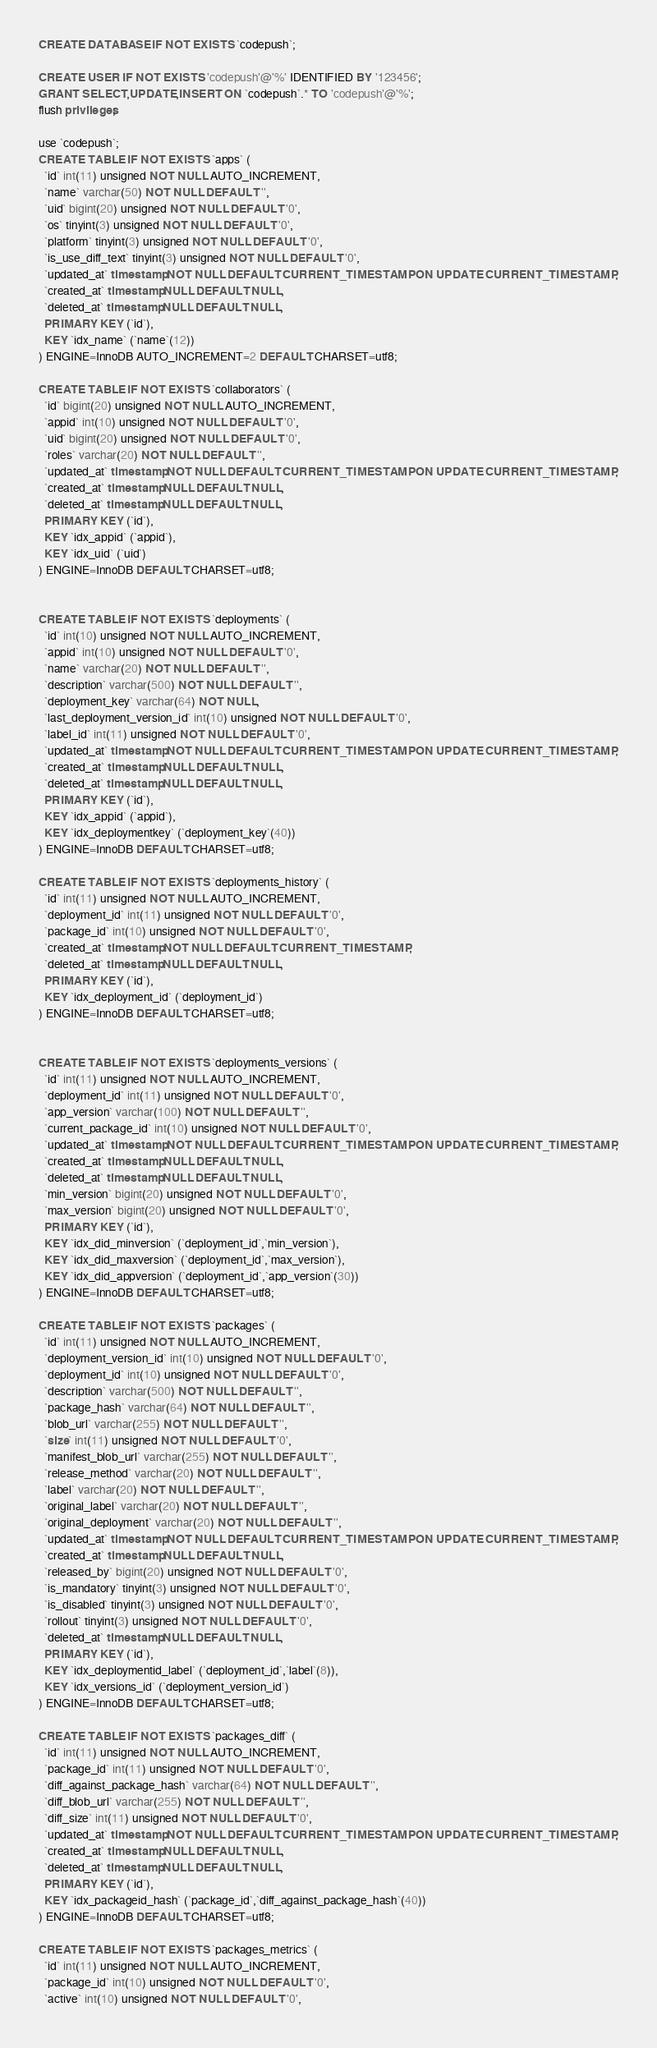<code> <loc_0><loc_0><loc_500><loc_500><_SQL_>CREATE DATABASE IF NOT EXISTS `codepush`;

CREATE USER IF NOT EXISTS 'codepush'@'%' IDENTIFIED BY '123456';
GRANT SELECT,UPDATE,INSERT ON `codepush`.* TO 'codepush'@'%';
flush privileges;

use `codepush`;
CREATE TABLE IF NOT EXISTS `apps` (
  `id` int(11) unsigned NOT NULL AUTO_INCREMENT,
  `name` varchar(50) NOT NULL DEFAULT '',
  `uid` bigint(20) unsigned NOT NULL DEFAULT '0',
  `os` tinyint(3) unsigned NOT NULL DEFAULT '0',
  `platform` tinyint(3) unsigned NOT NULL DEFAULT '0',
  `is_use_diff_text` tinyint(3) unsigned NOT NULL DEFAULT '0',
  `updated_at` timestamp NOT NULL DEFAULT CURRENT_TIMESTAMP ON UPDATE CURRENT_TIMESTAMP,
  `created_at` timestamp NULL DEFAULT NULL,
  `deleted_at` timestamp NULL DEFAULT NULL,
  PRIMARY KEY (`id`),
  KEY `idx_name` (`name`(12))
) ENGINE=InnoDB AUTO_INCREMENT=2 DEFAULT CHARSET=utf8;

CREATE TABLE IF NOT EXISTS `collaborators` (
  `id` bigint(20) unsigned NOT NULL AUTO_INCREMENT,
  `appid` int(10) unsigned NOT NULL DEFAULT '0',
  `uid` bigint(20) unsigned NOT NULL DEFAULT '0',
  `roles` varchar(20) NOT NULL DEFAULT '',
  `updated_at` timestamp NOT NULL DEFAULT CURRENT_TIMESTAMP ON UPDATE CURRENT_TIMESTAMP,
  `created_at` timestamp NULL DEFAULT NULL,
  `deleted_at` timestamp NULL DEFAULT NULL,
  PRIMARY KEY (`id`),
  KEY `idx_appid` (`appid`),
  KEY `idx_uid` (`uid`)
) ENGINE=InnoDB DEFAULT CHARSET=utf8;


CREATE TABLE IF NOT EXISTS `deployments` (
  `id` int(10) unsigned NOT NULL AUTO_INCREMENT,
  `appid` int(10) unsigned NOT NULL DEFAULT '0',
  `name` varchar(20) NOT NULL DEFAULT '',
  `description` varchar(500) NOT NULL DEFAULT '',
  `deployment_key` varchar(64) NOT NULL,
  `last_deployment_version_id` int(10) unsigned NOT NULL DEFAULT '0',
  `label_id` int(11) unsigned NOT NULL DEFAULT '0',
  `updated_at` timestamp NOT NULL DEFAULT CURRENT_TIMESTAMP ON UPDATE CURRENT_TIMESTAMP,
  `created_at` timestamp NULL DEFAULT NULL,
  `deleted_at` timestamp NULL DEFAULT NULL,
  PRIMARY KEY (`id`),
  KEY `idx_appid` (`appid`),
  KEY `idx_deploymentkey` (`deployment_key`(40))
) ENGINE=InnoDB DEFAULT CHARSET=utf8;

CREATE TABLE IF NOT EXISTS `deployments_history` (
  `id` int(11) unsigned NOT NULL AUTO_INCREMENT,
  `deployment_id` int(11) unsigned NOT NULL DEFAULT '0',
  `package_id` int(10) unsigned NOT NULL DEFAULT '0',
  `created_at` timestamp NOT NULL DEFAULT CURRENT_TIMESTAMP,
  `deleted_at` timestamp NULL DEFAULT NULL,
  PRIMARY KEY (`id`),
  KEY `idx_deployment_id` (`deployment_id`)
) ENGINE=InnoDB DEFAULT CHARSET=utf8;


CREATE TABLE IF NOT EXISTS `deployments_versions` (
  `id` int(11) unsigned NOT NULL AUTO_INCREMENT,
  `deployment_id` int(11) unsigned NOT NULL DEFAULT '0',
  `app_version` varchar(100) NOT NULL DEFAULT '',
  `current_package_id` int(10) unsigned NOT NULL DEFAULT '0',
  `updated_at` timestamp NOT NULL DEFAULT CURRENT_TIMESTAMP ON UPDATE CURRENT_TIMESTAMP,
  `created_at` timestamp NULL DEFAULT NULL,
  `deleted_at` timestamp NULL DEFAULT NULL,
  `min_version` bigint(20) unsigned NOT NULL DEFAULT '0',
  `max_version` bigint(20) unsigned NOT NULL DEFAULT '0',
  PRIMARY KEY (`id`),
  KEY `idx_did_minversion` (`deployment_id`,`min_version`),
  KEY `idx_did_maxversion` (`deployment_id`,`max_version`),
  KEY `idx_did_appversion` (`deployment_id`,`app_version`(30))
) ENGINE=InnoDB DEFAULT CHARSET=utf8;

CREATE TABLE IF NOT EXISTS `packages` (
  `id` int(11) unsigned NOT NULL AUTO_INCREMENT,
  `deployment_version_id` int(10) unsigned NOT NULL DEFAULT '0',
  `deployment_id` int(10) unsigned NOT NULL DEFAULT '0',
  `description` varchar(500) NOT NULL DEFAULT '',
  `package_hash` varchar(64) NOT NULL DEFAULT '',
  `blob_url` varchar(255) NOT NULL DEFAULT '',
  `size` int(11) unsigned NOT NULL DEFAULT '0',
  `manifest_blob_url` varchar(255) NOT NULL DEFAULT '',
  `release_method` varchar(20) NOT NULL DEFAULT '',
  `label` varchar(20) NOT NULL DEFAULT '',
  `original_label` varchar(20) NOT NULL DEFAULT '',
  `original_deployment` varchar(20) NOT NULL DEFAULT '',
  `updated_at` timestamp NOT NULL DEFAULT CURRENT_TIMESTAMP ON UPDATE CURRENT_TIMESTAMP,
  `created_at` timestamp NULL DEFAULT NULL,
  `released_by` bigint(20) unsigned NOT NULL DEFAULT '0',
  `is_mandatory` tinyint(3) unsigned NOT NULL DEFAULT '0',
  `is_disabled` tinyint(3) unsigned NOT NULL DEFAULT '0',
  `rollout` tinyint(3) unsigned NOT NULL DEFAULT '0',
  `deleted_at` timestamp NULL DEFAULT NULL,
  PRIMARY KEY (`id`),
  KEY `idx_deploymentid_label` (`deployment_id`,`label`(8)),
  KEY `idx_versions_id` (`deployment_version_id`)
) ENGINE=InnoDB DEFAULT CHARSET=utf8;

CREATE TABLE IF NOT EXISTS `packages_diff` (
  `id` int(11) unsigned NOT NULL AUTO_INCREMENT,
  `package_id` int(11) unsigned NOT NULL DEFAULT '0',
  `diff_against_package_hash` varchar(64) NOT NULL DEFAULT '',
  `diff_blob_url` varchar(255) NOT NULL DEFAULT '',
  `diff_size` int(11) unsigned NOT NULL DEFAULT '0',
  `updated_at` timestamp NOT NULL DEFAULT CURRENT_TIMESTAMP ON UPDATE CURRENT_TIMESTAMP,
  `created_at` timestamp NULL DEFAULT NULL,
  `deleted_at` timestamp NULL DEFAULT NULL,
  PRIMARY KEY (`id`),
  KEY `idx_packageid_hash` (`package_id`,`diff_against_package_hash`(40))
) ENGINE=InnoDB DEFAULT CHARSET=utf8;

CREATE TABLE IF NOT EXISTS `packages_metrics` (
  `id` int(11) unsigned NOT NULL AUTO_INCREMENT,
  `package_id` int(10) unsigned NOT NULL DEFAULT '0',
  `active` int(10) unsigned NOT NULL DEFAULT '0',</code> 